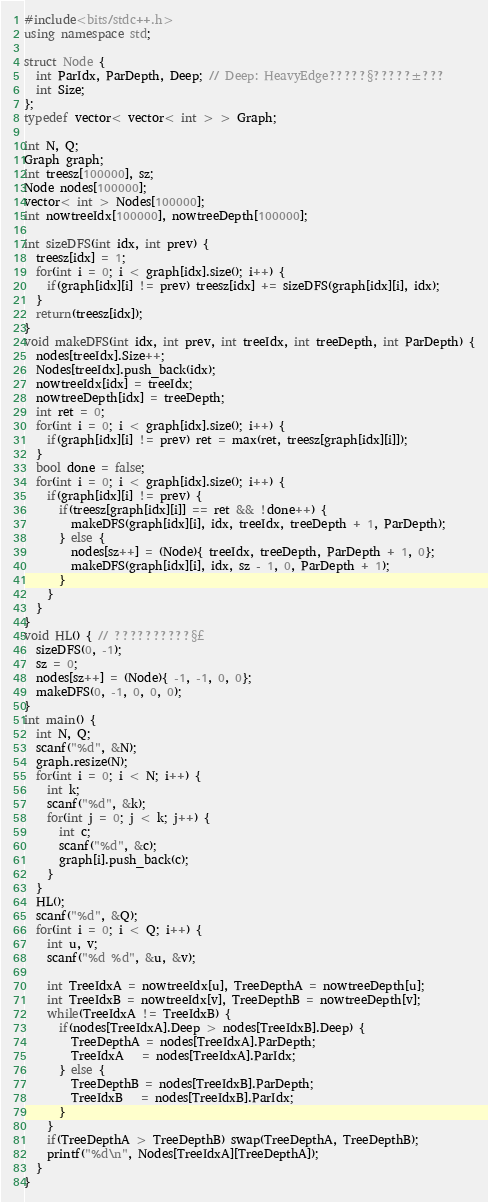<code> <loc_0><loc_0><loc_500><loc_500><_C++_>#include<bits/stdc++.h>
using namespace std;

struct Node {
  int ParIdx, ParDepth, Deep; // Deep: HeavyEdge?????§?????±???
  int Size;
};
typedef vector< vector< int > > Graph;

int N, Q;
Graph graph;
int treesz[100000], sz;
Node nodes[100000];
vector< int > Nodes[100000];
int nowtreeIdx[100000], nowtreeDepth[100000]; 

int sizeDFS(int idx, int prev) {
  treesz[idx] = 1;
  for(int i = 0; i < graph[idx].size(); i++) {
    if(graph[idx][i] != prev) treesz[idx] += sizeDFS(graph[idx][i], idx);
  }
  return(treesz[idx]);
}
void makeDFS(int idx, int prev, int treeIdx, int treeDepth, int ParDepth) {
  nodes[treeIdx].Size++;
  Nodes[treeIdx].push_back(idx);
  nowtreeIdx[idx] = treeIdx;
  nowtreeDepth[idx] = treeDepth;
  int ret = 0;
  for(int i = 0; i < graph[idx].size(); i++) {
    if(graph[idx][i] != prev) ret = max(ret, treesz[graph[idx][i]]);
  }
  bool done = false;
  for(int i = 0; i < graph[idx].size(); i++) {
    if(graph[idx][i] != prev) {
      if(treesz[graph[idx][i]] == ret && !done++) {
        makeDFS(graph[idx][i], idx, treeIdx, treeDepth + 1, ParDepth);
      } else {
        nodes[sz++] = (Node){ treeIdx, treeDepth, ParDepth + 1, 0};
        makeDFS(graph[idx][i], idx, sz - 1, 0, ParDepth + 1);
      }
    }
  }
}
void HL() { // ??????????§£
  sizeDFS(0, -1);
  sz = 0;
  nodes[sz++] = (Node){ -1, -1, 0, 0};
  makeDFS(0, -1, 0, 0, 0);
}
int main() {
  int N, Q;
  scanf("%d", &N);
  graph.resize(N);
  for(int i = 0; i < N; i++) {
    int k;
    scanf("%d", &k);
    for(int j = 0; j < k; j++) {
      int c;
      scanf("%d", &c);
      graph[i].push_back(c);
    }
  }
  HL();
  scanf("%d", &Q);
  for(int i = 0; i < Q; i++) {
    int u, v;
    scanf("%d %d", &u, &v);

    int TreeIdxA = nowtreeIdx[u], TreeDepthA = nowtreeDepth[u];
    int TreeIdxB = nowtreeIdx[v], TreeDepthB = nowtreeDepth[v];
    while(TreeIdxA != TreeIdxB) {
      if(nodes[TreeIdxA].Deep > nodes[TreeIdxB].Deep) {
        TreeDepthA = nodes[TreeIdxA].ParDepth;
        TreeIdxA   = nodes[TreeIdxA].ParIdx;
      } else {
        TreeDepthB = nodes[TreeIdxB].ParDepth;
        TreeIdxB   = nodes[TreeIdxB].ParIdx;
      }
    }
    if(TreeDepthA > TreeDepthB) swap(TreeDepthA, TreeDepthB);
    printf("%d\n", Nodes[TreeIdxA][TreeDepthA]);
  }
}</code> 